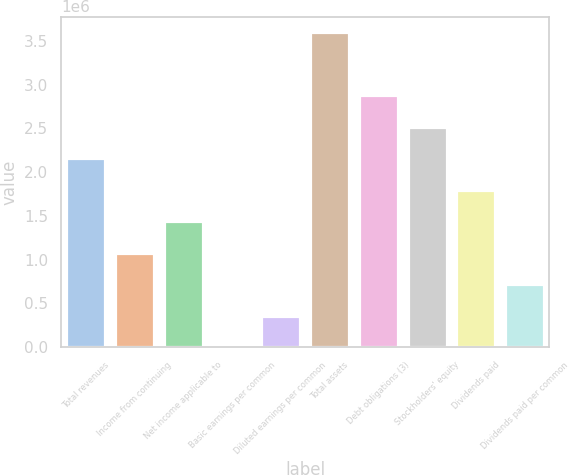Convert chart to OTSL. <chart><loc_0><loc_0><loc_500><loc_500><bar_chart><fcel>Total revenues<fcel>Income from continuing<fcel>Net income applicable to<fcel>Basic earnings per common<fcel>Diluted earnings per common<fcel>Total assets<fcel>Debt obligations (3)<fcel>Stockholders' equity<fcel>Dividends paid<fcel>Dividends paid per common<nl><fcel>2.15836e+06<fcel>1.07918e+06<fcel>1.43891e+06<fcel>0.19<fcel>359727<fcel>3.59726e+06<fcel>2.87781e+06<fcel>2.51809e+06<fcel>1.79863e+06<fcel>719453<nl></chart> 